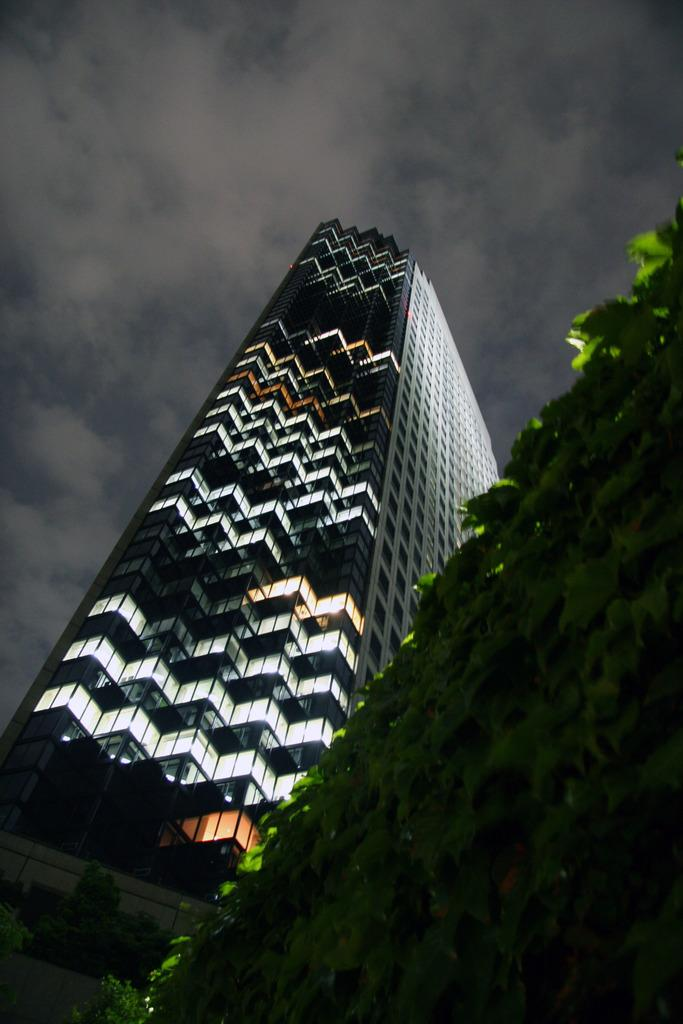What natural element is present in the image? There is a tree in the image. What man-made structure can be seen in the background of the image? There is a big building in the background of the image. What is the condition of the sky in the image? The sky is cloudy in the background of the image. How many trains can be seen passing by the tree in the image? There are no trains present in the image. Who is the creator of the tree in the image? The tree is a natural element and does not have a creator. 